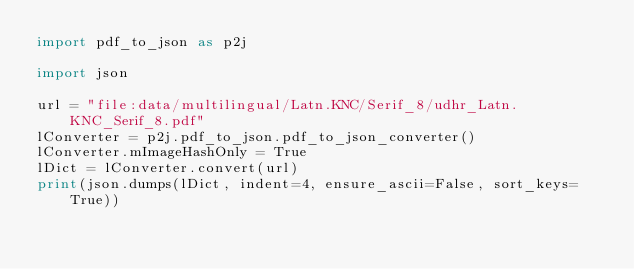Convert code to text. <code><loc_0><loc_0><loc_500><loc_500><_Python_>import pdf_to_json as p2j

import json

url = "file:data/multilingual/Latn.KNC/Serif_8/udhr_Latn.KNC_Serif_8.pdf"
lConverter = p2j.pdf_to_json.pdf_to_json_converter()
lConverter.mImageHashOnly = True
lDict = lConverter.convert(url)
print(json.dumps(lDict, indent=4, ensure_ascii=False, sort_keys=True))
</code> 